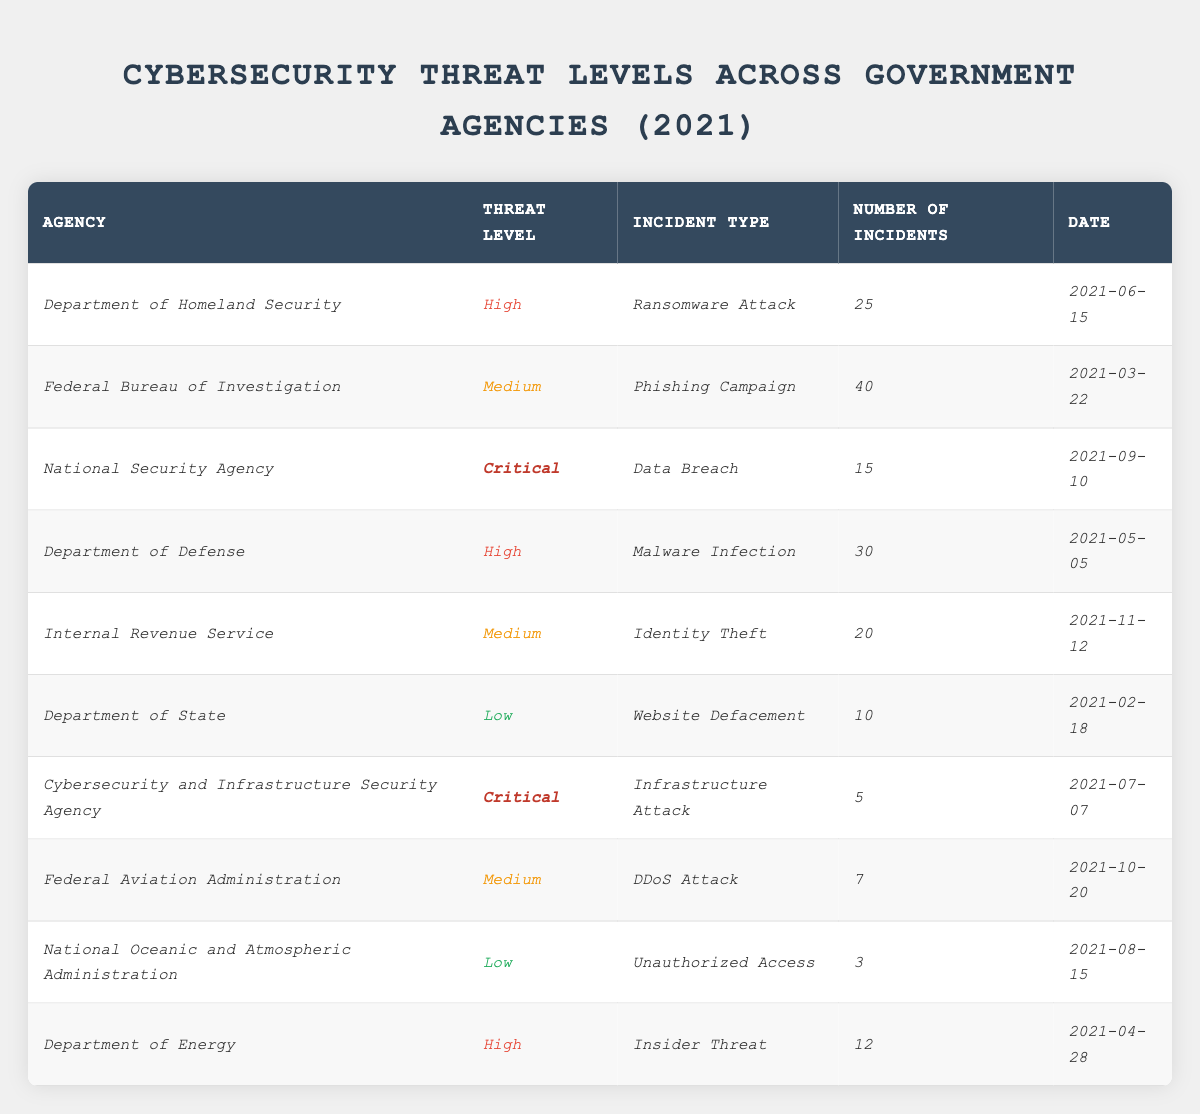What is the highest threat level among the agencies listed? The table provides several threat levels for different agencies. On reviewing the entries, I see that "Critical" is the highest threat level, which appears for the National Security Agency and Cybersecurity and Infrastructure Security Agency.
Answer: Critical Which agency had the most number of incidents in 2021? By examining the table, the agency with the highest number of incidents is the Federal Bureau of Investigation, reporting 40 incidents related to a Phishing Campaign.
Answer: Federal Bureau of Investigation How many incidents categorized as 'High' were reported? The agencies with a "High" threat level are the Department of Homeland Security, Department of Defense, and Department of Energy. They reported 25, 30, and 12 incidents, respectively. Summing these gives 25 + 30 + 12 = 67 incidents.
Answer: 67 Is there a 'Low' threat level agency that reported more than 5 incidents? The National Oceanic and Atmospheric Administration and Department of State both have a 'Low' threat level. The former reported 3 incidents and the latter reported 10 incidents. Since 10 is greater than 5, the Department of State fits the criteria.
Answer: Yes What is the average number of incidents for agencies with 'Medium' threat levels? The agencies in the 'Medium' threat level are the Federal Bureau of Investigation, Internal Revenue Service, and Federal Aviation Administration, which reported 40, 20, and 7 incidents respectively. The total incidents are 40 + 20 + 7 = 67, and there are 3 agencies, so the average is 67 / 3 = 22.33.
Answer: 22.33 Which incident type was reported by the agency with the 'Critical' threat level that had the least incidents? The table shows that the Cybersecurity and Infrastructure Security Agency had the least incidents with 5 during an Infrastructure Attack, while the National Security Agency had 15 from a Data Breach. Since 5 is less than 15, Infrastructure Attack is the answer.
Answer: Infrastructure Attack How many total incidents were reported in 2021 across all agencies? Adding up all reported incidents across all agencies: 25 (DHS) + 40 (FBI) + 15 (NSA) + 30 (DoD) + 20 (IRS) + 10 (DoS) + 5 (CISA) + 7 (FAA) + 3 (NOAA) + 12 (DoE) gives a total of 25 + 40 + 15 + 30 + 20 + 10 + 5 + 7 + 3 + 12 = 167 incidents.
Answer: 167 Which agency experienced a Ransomware Attack? According to the table, the Department of Homeland Security experienced a Ransomware Attack, which had a threat level of High.
Answer: Department of Homeland Security How many agencies reported a 'Critical' threat level? The table shows two agencies reported a 'Critical' threat level: the National Security Agency and the Cybersecurity and Infrastructure Security Agency. Thus, the answer is two.
Answer: 2 Did the Internal Revenue Service have the highest threat level among all agencies? Reviewing the threat levels in the table, the IRS is categorized as having a 'Medium' threat level, which is lower than 'High' and 'Critical'. Therefore, the IRS does not have the highest threat level.
Answer: No 